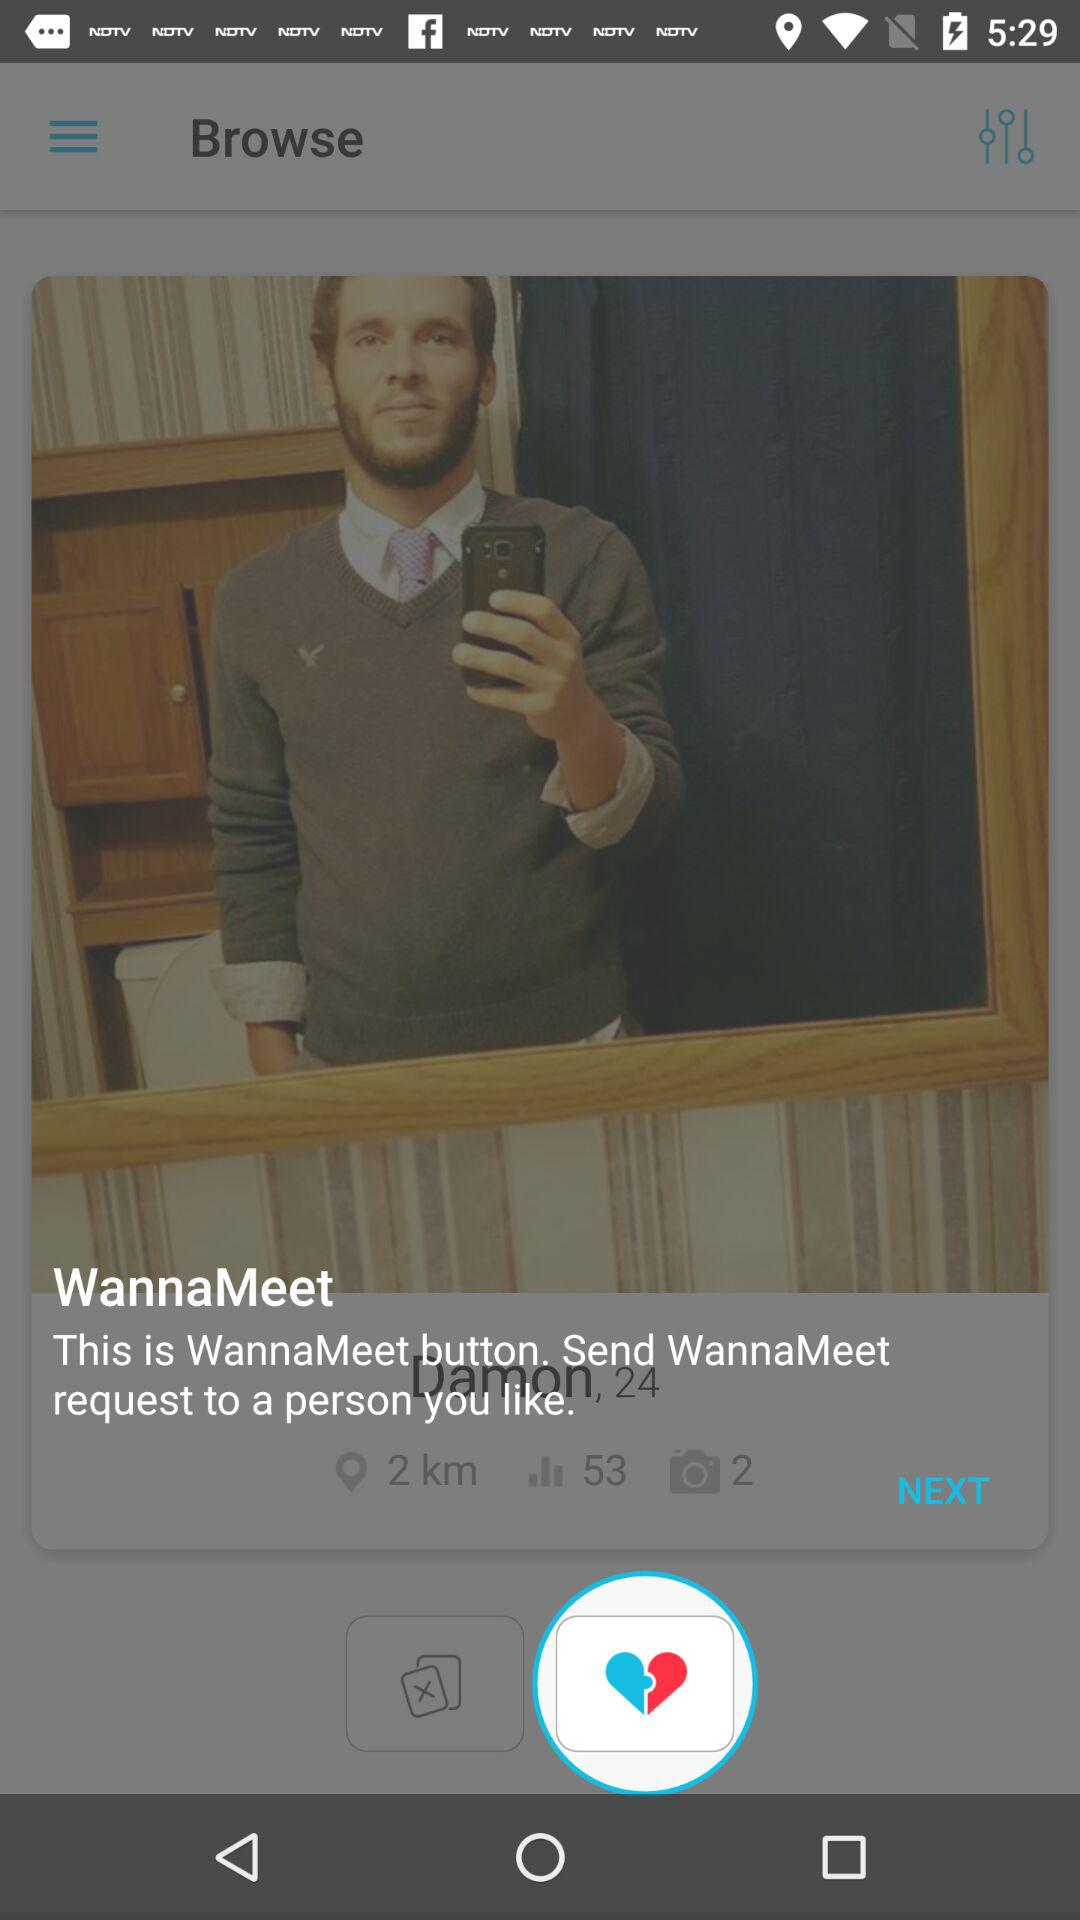What is the name of the currently highlighted button? The name of the currently highlighted button is "WannaMeet". 